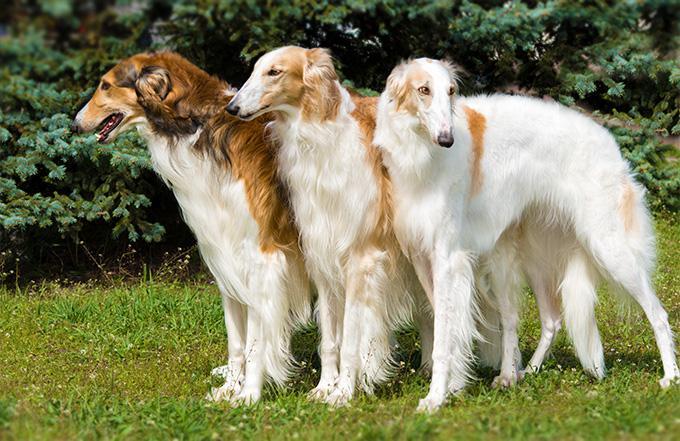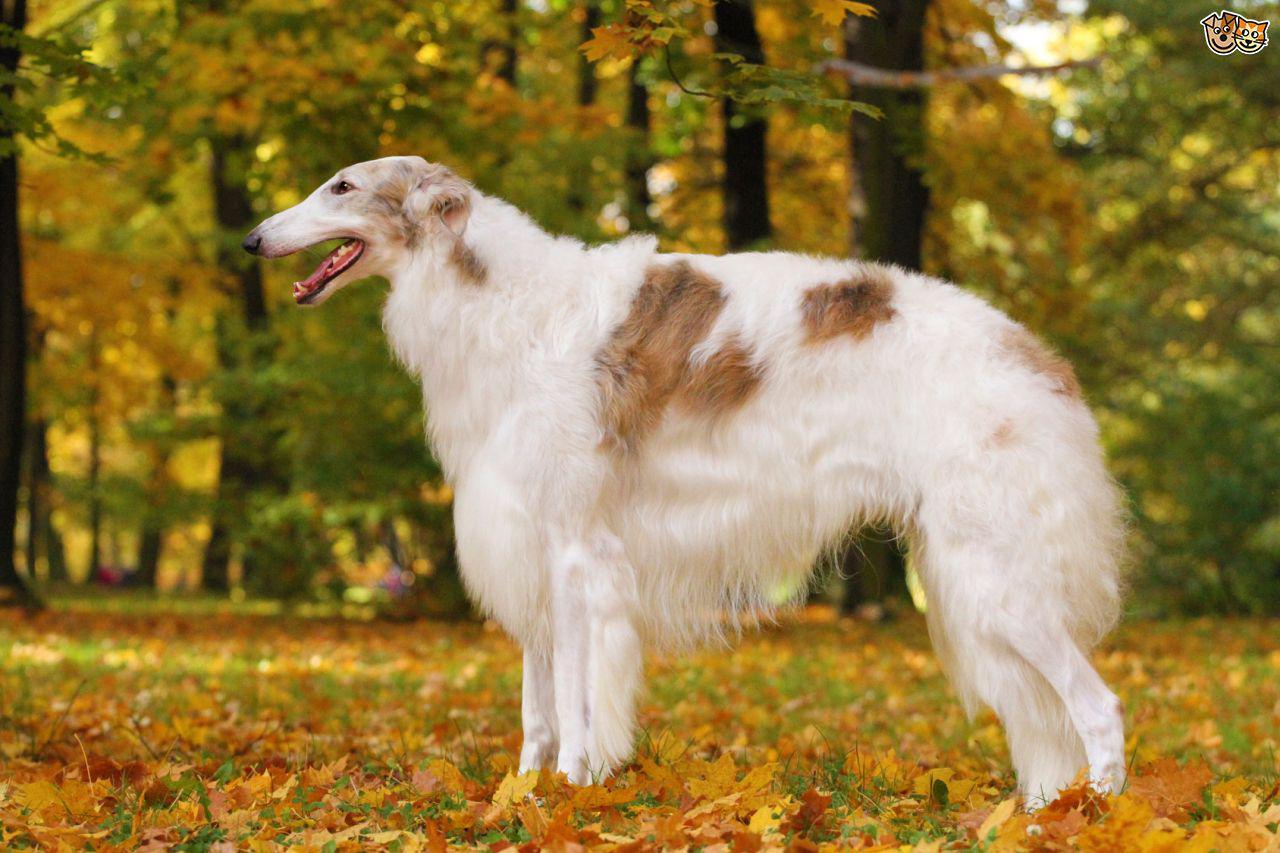The first image is the image on the left, the second image is the image on the right. Evaluate the accuracy of this statement regarding the images: "In one of the images there are two dogs standing in the grass in close proximity to each other.". Is it true? Answer yes or no. No. The first image is the image on the left, the second image is the image on the right. Analyze the images presented: Is the assertion "All dogs pictured are standing on all fours on grass, and the right image contains more dogs than the left." valid? Answer yes or no. No. 